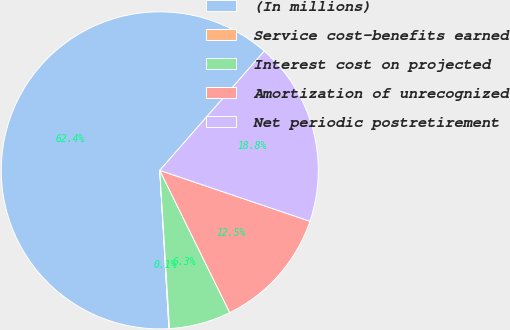<chart> <loc_0><loc_0><loc_500><loc_500><pie_chart><fcel>(In millions)<fcel>Service cost-benefits earned<fcel>Interest cost on projected<fcel>Amortization of unrecognized<fcel>Net periodic postretirement<nl><fcel>62.36%<fcel>0.07%<fcel>6.29%<fcel>12.52%<fcel>18.75%<nl></chart> 